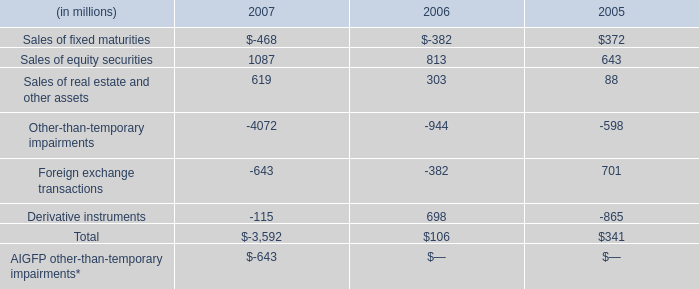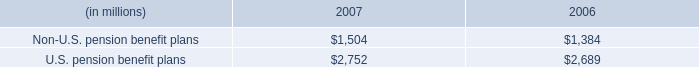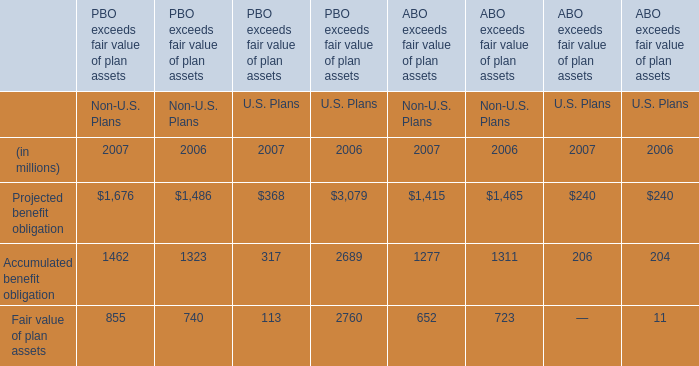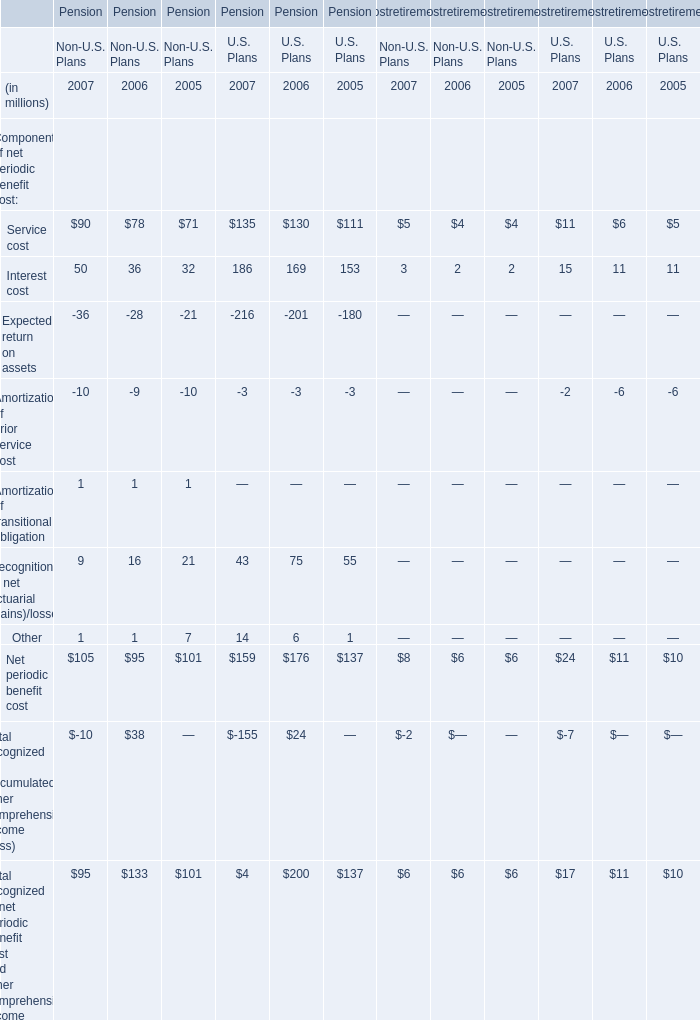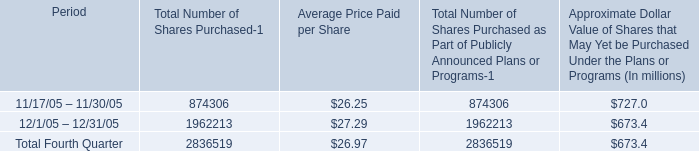Which element continue to rise between 2006 and 2007? 
Answer: Non-U.S. pension benefit plans,U.S. pension benefit plans. 